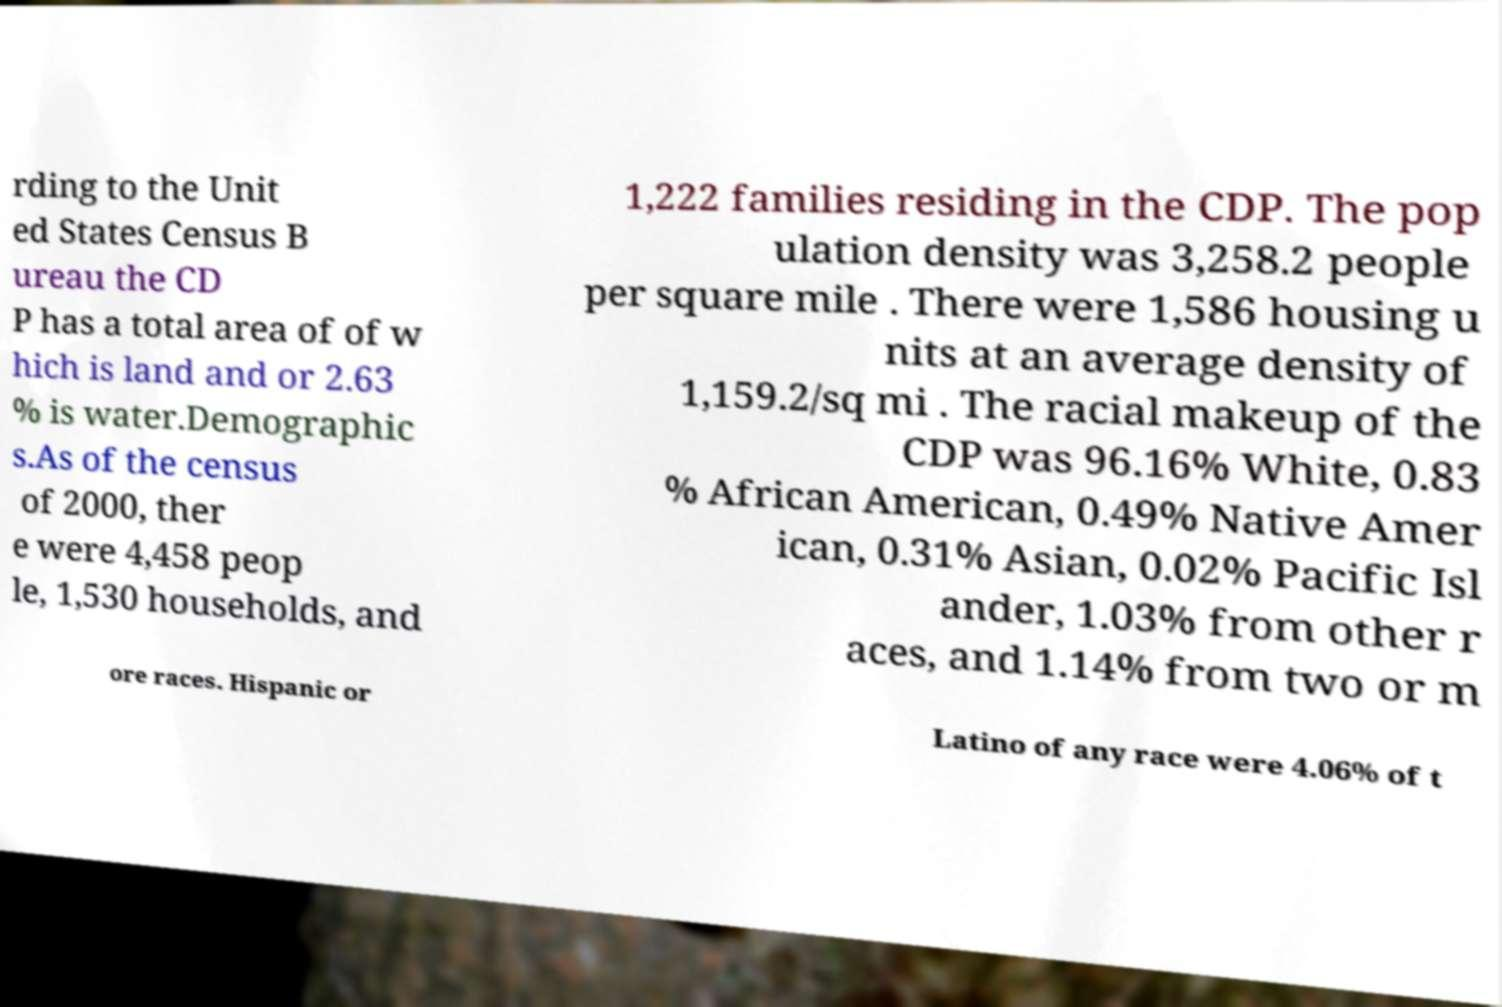Can you read and provide the text displayed in the image?This photo seems to have some interesting text. Can you extract and type it out for me? rding to the Unit ed States Census B ureau the CD P has a total area of of w hich is land and or 2.63 % is water.Demographic s.As of the census of 2000, ther e were 4,458 peop le, 1,530 households, and 1,222 families residing in the CDP. The pop ulation density was 3,258.2 people per square mile . There were 1,586 housing u nits at an average density of 1,159.2/sq mi . The racial makeup of the CDP was 96.16% White, 0.83 % African American, 0.49% Native Amer ican, 0.31% Asian, 0.02% Pacific Isl ander, 1.03% from other r aces, and 1.14% from two or m ore races. Hispanic or Latino of any race were 4.06% of t 